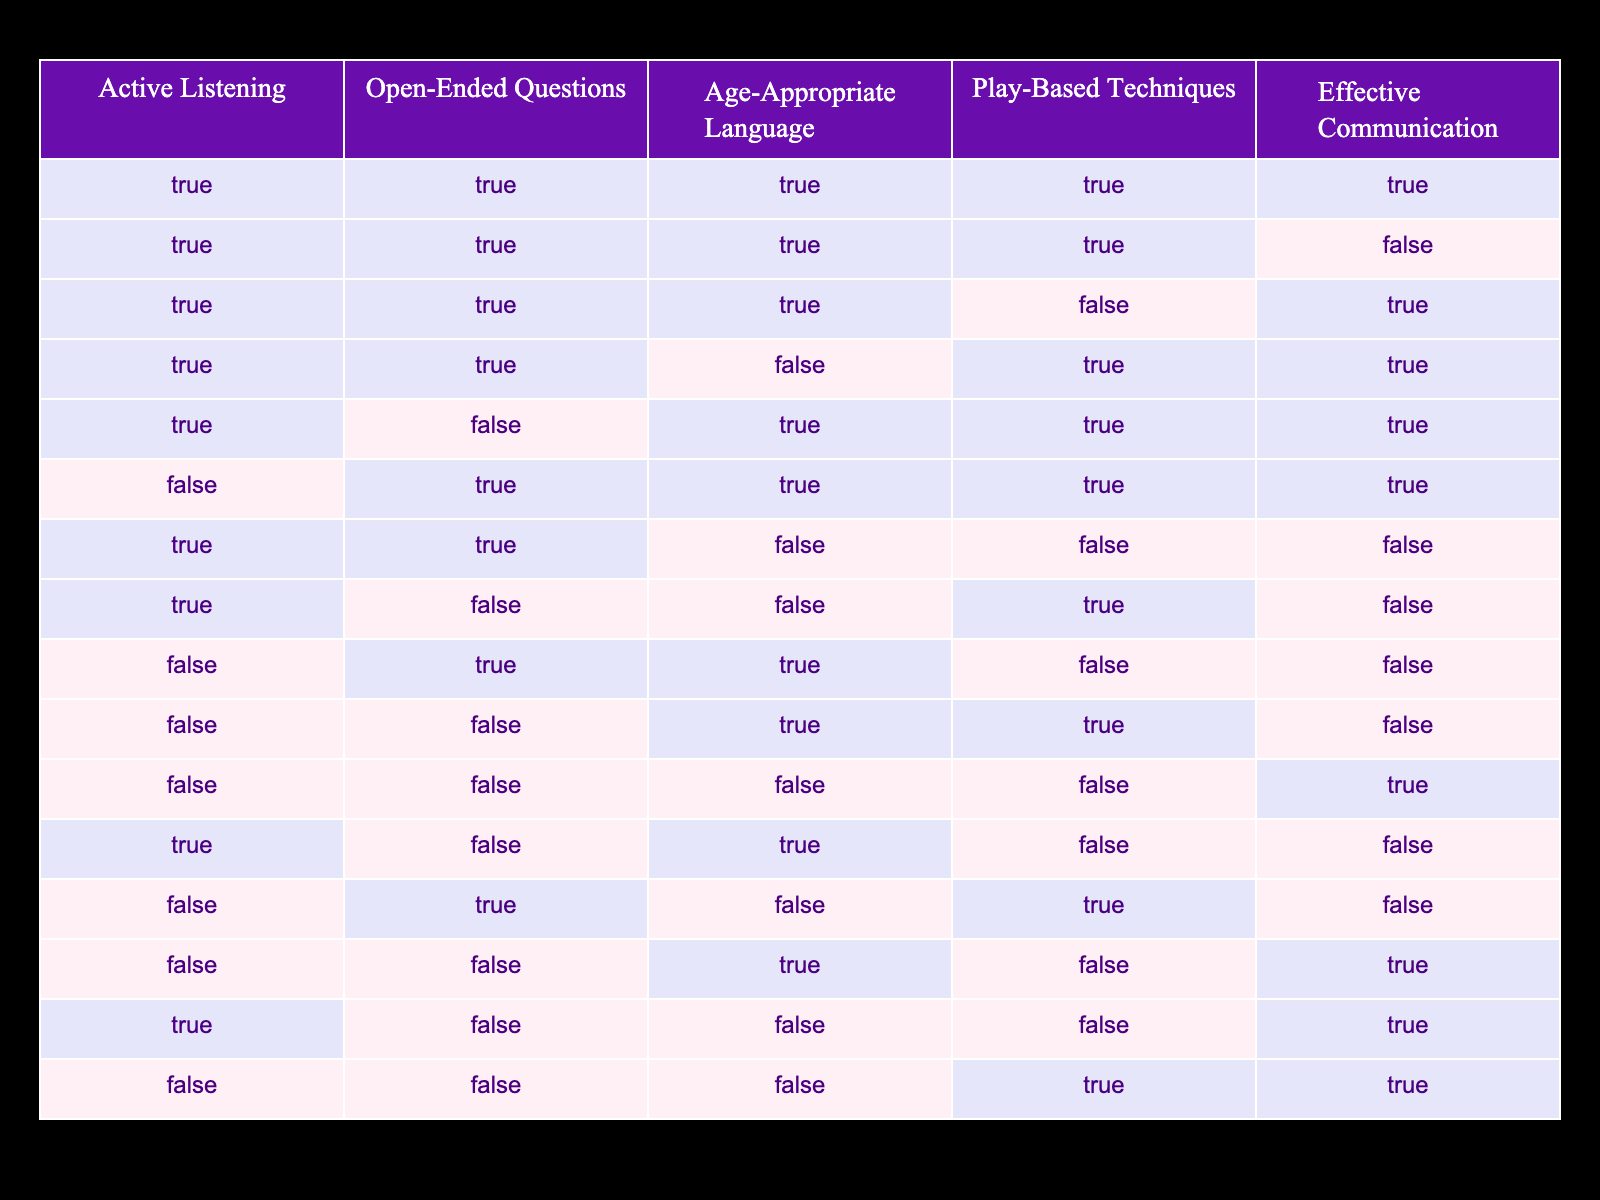What is the total number of strategies that include Active Listening? By counting the rows where Active Listening is TRUE, I find there are 7 rows.
Answer: 7 How many strategies incorporate Open-Ended Questions but not Play-Based Techniques? There are 3 rows where Open-Ended Questions is TRUE and Play-Based Techniques is FALSE: (TRUE, TRUE, FALSE), (FALSE, TRUE, FALSE), (FALSE, TRUE, FALSE). The total is 3.
Answer: 3 Is it true that all effective communication strategies use Age-Appropriate Language? No, only 5 out of 16 rows indicate effective communication while using Age-Appropriate Language is FALSE, which means not all strategies do.
Answer: No How many rows have all four strategies set to TRUE? There is only 1 row that has Active Listening, Open-Ended Questions, Age-Appropriate Language, and Play-Based Techniques all as TRUE, which indicates the most comprehensive strategy.
Answer: 1 Can you identify how many strategies utilize effective communication while employing Play-Based Techniques? Looking at the table, there are 6 rows where Effective Communication is TRUE and Play-Based Techniques is TRUE. The specific rows can be viewed for detail.
Answer: 6 What percentage of strategies employs Age-Appropriate Language? There are 8 rows where Age-Appropriate Language is TRUE. There are 16 total rows, so (8/16)*100 = 50%.
Answer: 50% What is the relationship between using Open-Ended Questions and Effective Communication? By filtering the table, I see that out of the 6 instances where Effective Communication is TRUE, 5 of these also incorporate Open-Ended Questions. Thus, most effective communication strategies employ Open-Ended Questions.
Answer: They are positively correlated Is it possible to have effective communication without Age-Appropriate Language? Yes, by checking the table, there are 4 instances where Effective Communication is TRUE while Age-Appropriate Language is FALSE.
Answer: Yes 